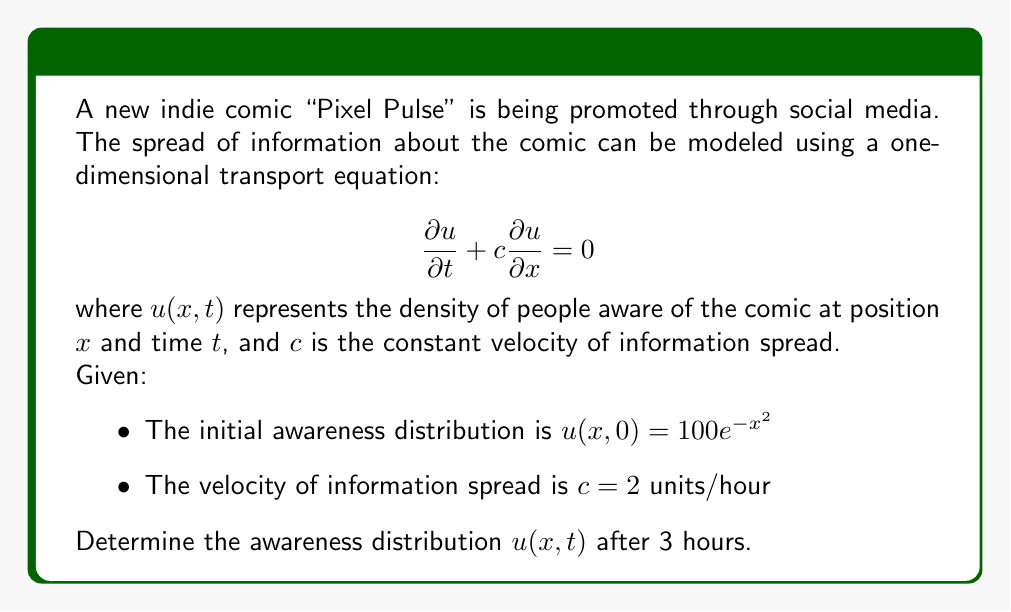Teach me how to tackle this problem. To solve this problem, we'll use the method of characteristics for the transport equation.

1) The general solution to the transport equation is:
   $$u(x,t) = f(x - ct)$$
   where $f$ is determined by the initial condition.

2) At $t=0$, we have:
   $$u(x,0) = 100e^{-x^2} = f(x)$$

3) Therefore, the solution is:
   $$u(x,t) = 100e^{-(x-ct)^2}$$

4) Substituting the given values:
   $c = 2$ units/hour
   $t = 3$ hours

5) The final solution is:
   $$u(x,3) = 100e^{-(x-6)^2}$$

This represents the awareness distribution after 3 hours. The peak of awareness has shifted 6 units to the right (2 units/hour * 3 hours = 6 units) from its initial position at $x=0$.
Answer: $u(x,3) = 100e^{-(x-6)^2}$ 